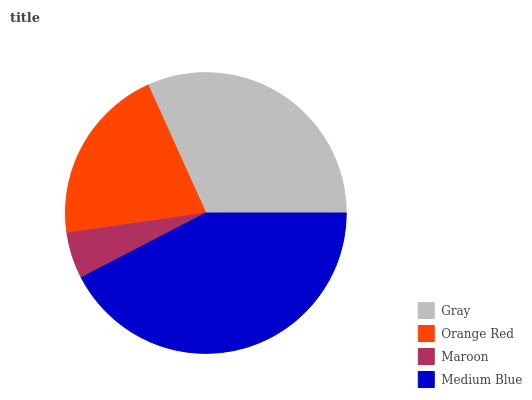Is Maroon the minimum?
Answer yes or no. Yes. Is Medium Blue the maximum?
Answer yes or no. Yes. Is Orange Red the minimum?
Answer yes or no. No. Is Orange Red the maximum?
Answer yes or no. No. Is Gray greater than Orange Red?
Answer yes or no. Yes. Is Orange Red less than Gray?
Answer yes or no. Yes. Is Orange Red greater than Gray?
Answer yes or no. No. Is Gray less than Orange Red?
Answer yes or no. No. Is Gray the high median?
Answer yes or no. Yes. Is Orange Red the low median?
Answer yes or no. Yes. Is Maroon the high median?
Answer yes or no. No. Is Medium Blue the low median?
Answer yes or no. No. 